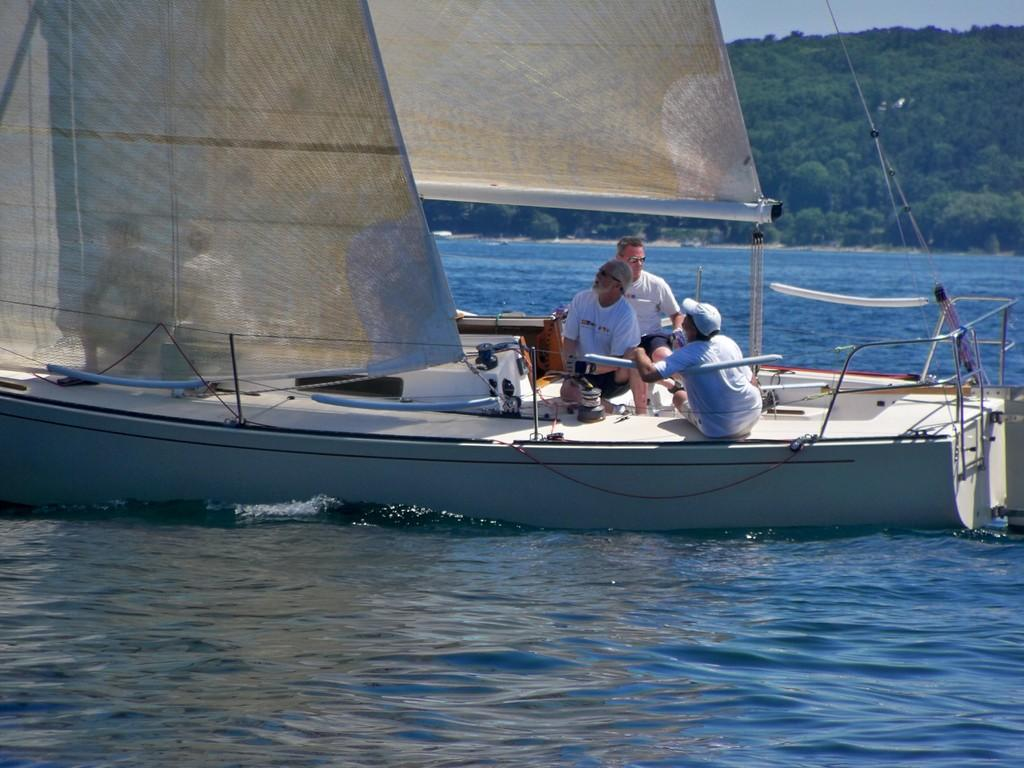How many people are in the image? There are three men in the image. What are the men doing in the image? The men are sitting on a boat. Where is the boat located? The boat is on water. What can be seen in the background of the image? There are trees and the sky visible in the background. What type of property is being offered by the men in the image? There is no indication in the image that the men are offering any property. 